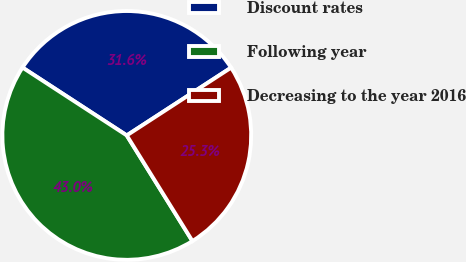<chart> <loc_0><loc_0><loc_500><loc_500><pie_chart><fcel>Discount rates<fcel>Following year<fcel>Decreasing to the year 2016<nl><fcel>31.65%<fcel>43.04%<fcel>25.32%<nl></chart> 